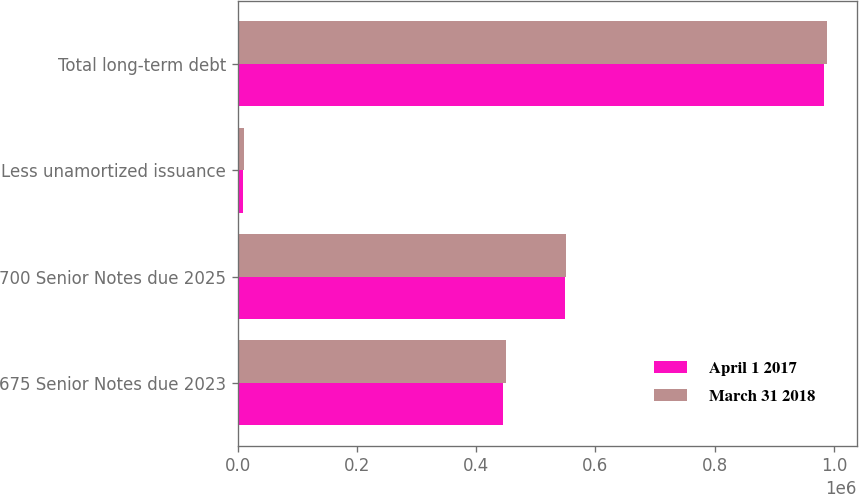Convert chart. <chart><loc_0><loc_0><loc_500><loc_500><stacked_bar_chart><ecel><fcel>675 Senior Notes due 2023<fcel>700 Senior Notes due 2025<fcel>Less unamortized issuance<fcel>Total long-term debt<nl><fcel>April 1 2017<fcel>444464<fcel>548500<fcel>9674<fcel>983290<nl><fcel>March 31 2018<fcel>450000<fcel>550000<fcel>10846<fcel>989154<nl></chart> 